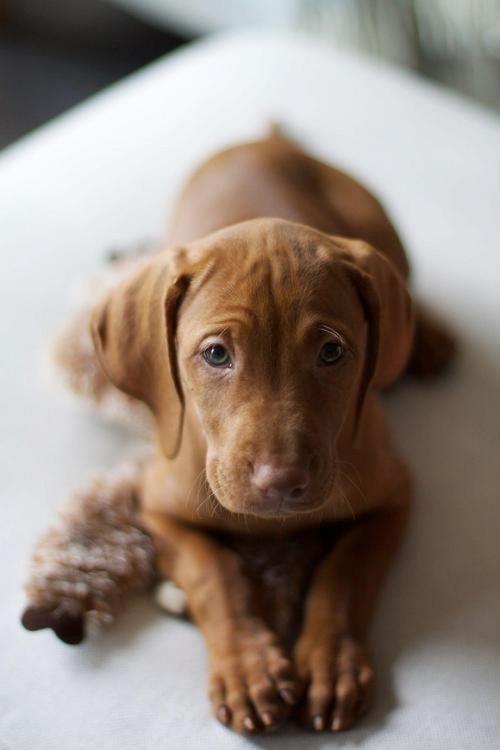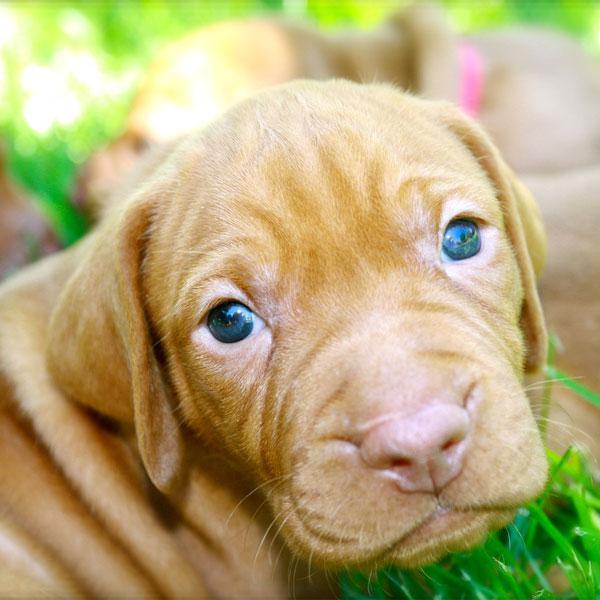The first image is the image on the left, the second image is the image on the right. Analyze the images presented: Is the assertion "The right image features one camera-gazing puppy with fully open eyes, and the left image features one reclining puppy with its front paws forward." valid? Answer yes or no. Yes. The first image is the image on the left, the second image is the image on the right. Considering the images on both sides, is "A dog is wearing a collar." valid? Answer yes or no. No. 